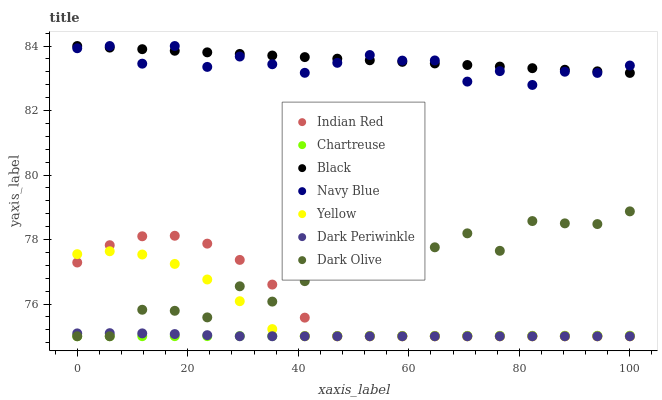Does Chartreuse have the minimum area under the curve?
Answer yes or no. Yes. Does Black have the maximum area under the curve?
Answer yes or no. Yes. Does Dark Olive have the minimum area under the curve?
Answer yes or no. No. Does Dark Olive have the maximum area under the curve?
Answer yes or no. No. Is Black the smoothest?
Answer yes or no. Yes. Is Dark Olive the roughest?
Answer yes or no. Yes. Is Yellow the smoothest?
Answer yes or no. No. Is Yellow the roughest?
Answer yes or no. No. Does Dark Olive have the lowest value?
Answer yes or no. Yes. Does Black have the lowest value?
Answer yes or no. No. Does Black have the highest value?
Answer yes or no. Yes. Does Dark Olive have the highest value?
Answer yes or no. No. Is Indian Red less than Black?
Answer yes or no. Yes. Is Black greater than Yellow?
Answer yes or no. Yes. Does Yellow intersect Chartreuse?
Answer yes or no. Yes. Is Yellow less than Chartreuse?
Answer yes or no. No. Is Yellow greater than Chartreuse?
Answer yes or no. No. Does Indian Red intersect Black?
Answer yes or no. No. 